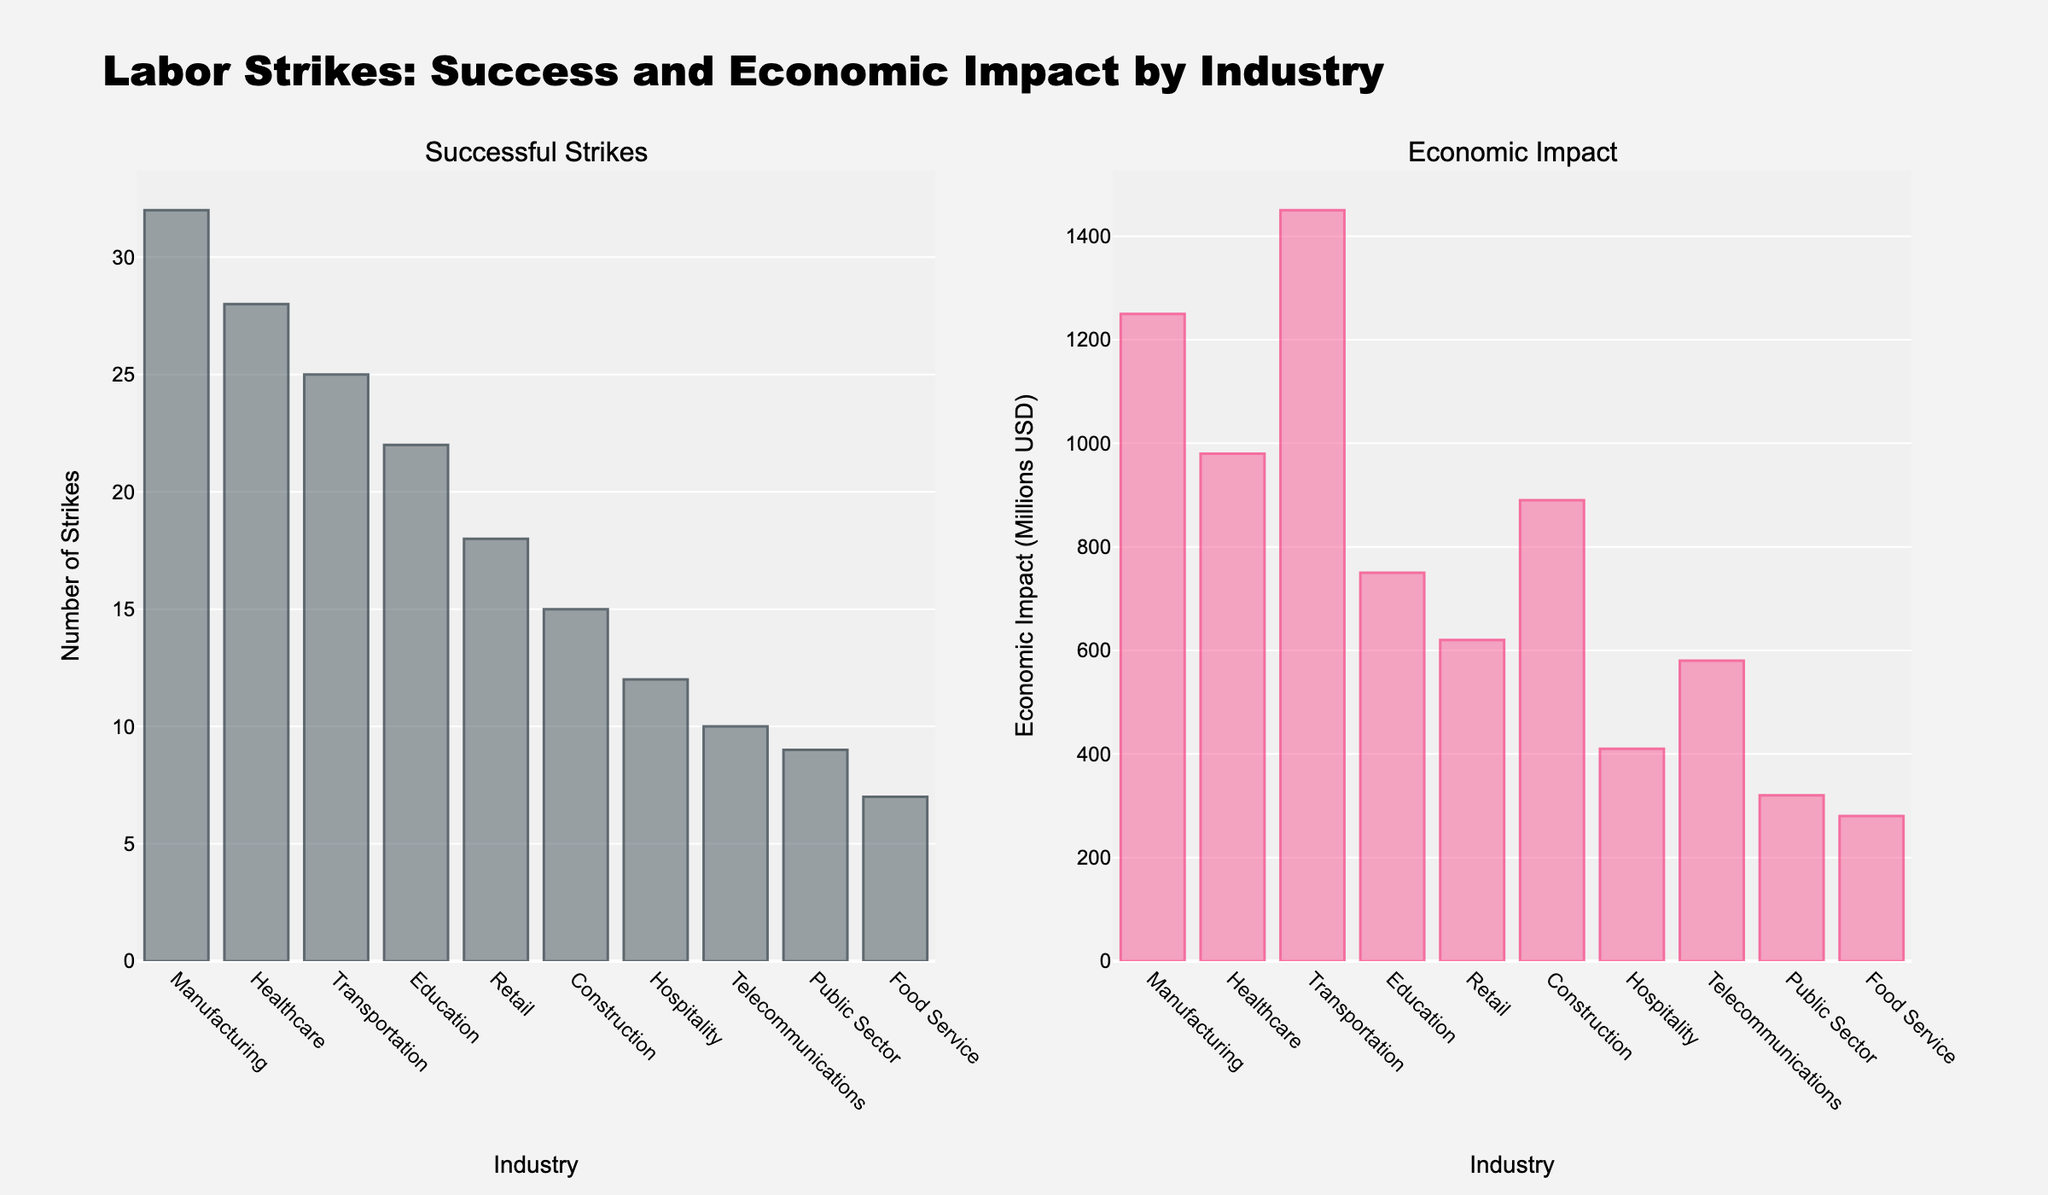Which industry has the highest number of successful strikes? The bar representing "Manufacturing" has the greatest height in the "Successful Strikes" subplot, which indicates it has the highest count.
Answer: Manufacturing What is the combined economic impact of successful strikes in the Transportation and Telecommunications industries? According to the "Economic Impact" subplot, Transportation has an impact of 1450 million USD and Telecommunications has 580 million USD. Adding these together gives 1450 + 580 = 2030 million USD.
Answer: 2030 million USD Which industry has a lower economic impact: Healthcare or Construction? The "Economic Impact" subplot shows that Healthcare's bar is shorter than Construction's, indicating Healthcare's 980 million USD is less than Construction’s 890 million USD.
Answer: Construction How many more successful strikes are there in Education compared to Food Service? The "Successful Strikes" subplot shows Education with 22 strikes and Food Service with 7. The difference is 22 - 7 = 15.
Answer: 15 Which industry has the lowest economic impact from successful strikes? In the "Economic Impact" subplot, the shortest bar corresponds to "Public Sector," which has a 320 million USD impact.
Answer: Public Sector In terms of successful strikes, which industry follows Manufacturing and by how much is it behind? Manufacturing has 32 successful strikes and the next highest is Healthcare with 28. The difference is 32 - 28 = 4.
Answer: Healthcare, 4 What is the average economic impact for the industries shown? To find the average, sum the economic impacts and divide by the number of industries: (1250 + 980 + 1450 + 750 + 620 + 890 + 410 + 580 + 320 + 280) / 10 = 7530 / 10 = 753 million USD.
Answer: 753 million USD If you combine the number of successful strikes from the Retail and Hospitality industries, how many strikes are there in total? Retail has 18 strikes and Hospitality has 12. Adding these gives 18 + 12 = 30 successful strikes.
Answer: 30 Which industry has a greater economic impact: Telecommunications or Food Service, and by how much? The "Economic Impact" subplot shows Telecommunications with 580 million USD and Food Service with 280 million USD. The difference is 580 - 280 = 300 million USD.
Answer: Telecommunications, 300 million USD Rank the top three industries based on the number of successful strikes. From the "Successful Strikes" subplot: 1) Manufacturing (32), 2) Healthcare (28), 3) Transportation (25).
Answer: 1) Manufacturing, 2) Healthcare, 3) Transportation 